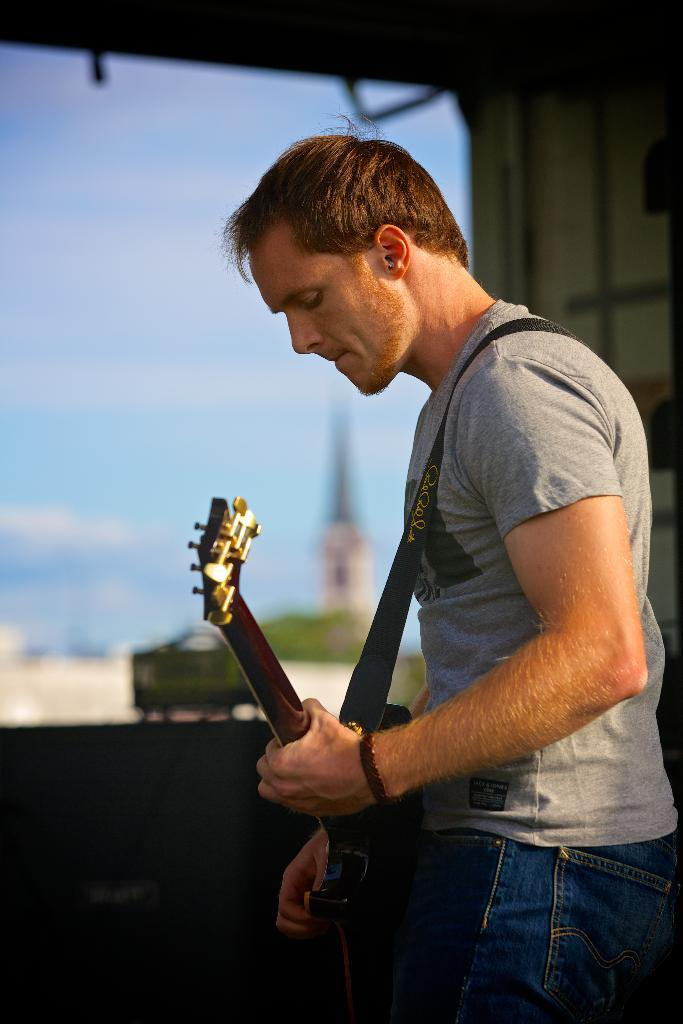What is the main subject of the image? There is a man in the image. What is the man doing in the image? The man is standing and playing a guitar. What can be seen in the background of the image? There are plants and the sky visible in the background of the image. Can you hear the jellyfish singing along with the man in the image? There are no jellyfish present in the image, so it is not possible to hear them singing along with the man. 